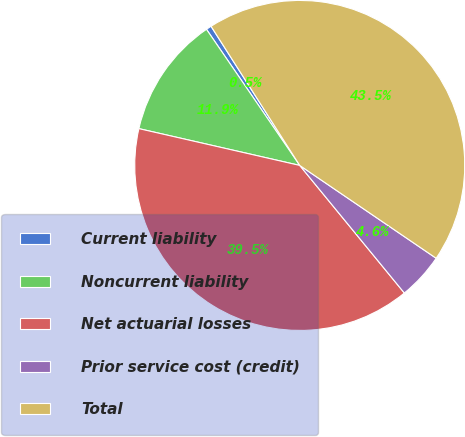<chart> <loc_0><loc_0><loc_500><loc_500><pie_chart><fcel>Current liability<fcel>Noncurrent liability<fcel>Net actuarial losses<fcel>Prior service cost (credit)<fcel>Total<nl><fcel>0.53%<fcel>11.86%<fcel>39.51%<fcel>4.56%<fcel>43.54%<nl></chart> 